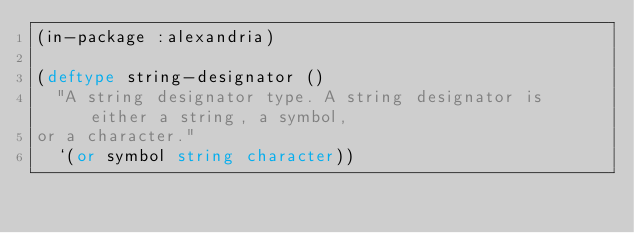Convert code to text. <code><loc_0><loc_0><loc_500><loc_500><_Lisp_>(in-package :alexandria)

(deftype string-designator ()
  "A string designator type. A string designator is either a string, a symbol,
or a character."
  `(or symbol string character))
</code> 